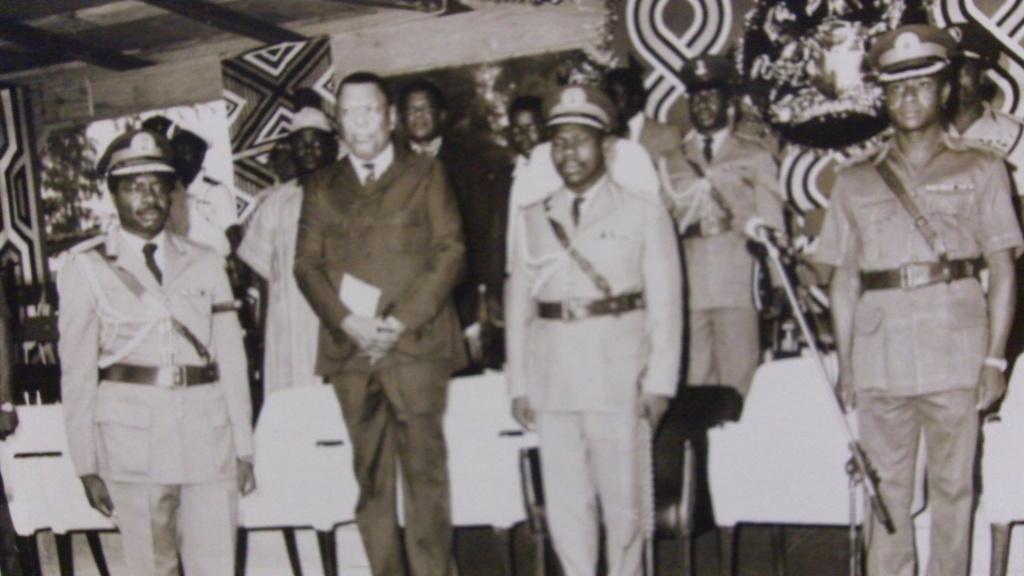Could you give a brief overview of what you see in this image? In this image I can see the black and white picture of two persons wearing uniform and a person wearing blazer, pant and shirt are standing. In the background I can see few other persons standing, the wall, few trees and the ceiling. 